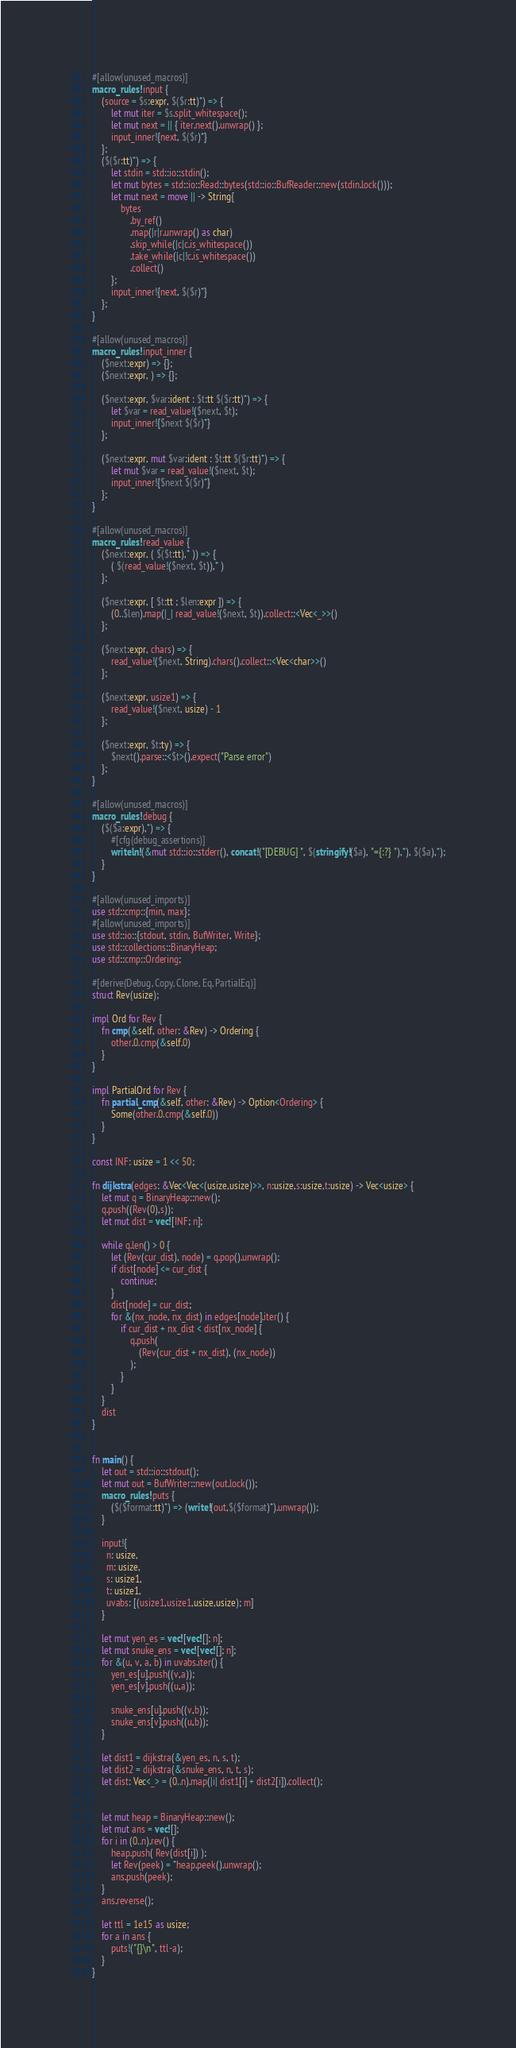<code> <loc_0><loc_0><loc_500><loc_500><_Rust_>#[allow(unused_macros)]
macro_rules! input {
    (source = $s:expr, $($r:tt)*) => {
        let mut iter = $s.split_whitespace();
        let mut next = || { iter.next().unwrap() };
        input_inner!{next, $($r)*}
    };
    ($($r:tt)*) => {
        let stdin = std::io::stdin();
        let mut bytes = std::io::Read::bytes(std::io::BufReader::new(stdin.lock()));
        let mut next = move || -> String{
            bytes
                .by_ref()
                .map(|r|r.unwrap() as char)
                .skip_while(|c|c.is_whitespace())
                .take_while(|c|!c.is_whitespace())
                .collect()
        };
        input_inner!{next, $($r)*}
    };
}

#[allow(unused_macros)]
macro_rules! input_inner {
    ($next:expr) => {};
    ($next:expr, ) => {};

    ($next:expr, $var:ident : $t:tt $($r:tt)*) => {
        let $var = read_value!($next, $t);
        input_inner!{$next $($r)*}
    };

    ($next:expr, mut $var:ident : $t:tt $($r:tt)*) => {
        let mut $var = read_value!($next, $t);
        input_inner!{$next $($r)*}
    };
}

#[allow(unused_macros)]
macro_rules! read_value {
    ($next:expr, ( $($t:tt),* )) => {
        ( $(read_value!($next, $t)),* )
    };

    ($next:expr, [ $t:tt ; $len:expr ]) => {
        (0..$len).map(|_| read_value!($next, $t)).collect::<Vec<_>>()
    };

    ($next:expr, chars) => {
        read_value!($next, String).chars().collect::<Vec<char>>()
    };

    ($next:expr, usize1) => {
        read_value!($next, usize) - 1
    };

    ($next:expr, $t:ty) => {
        $next().parse::<$t>().expect("Parse error")
    };
}

#[allow(unused_macros)]
macro_rules! debug {
    ($($a:expr),*) => {
        #[cfg(debug_assertions)]
        writeln!(&mut std::io::stderr(), concat!("[DEBUG] ", $(stringify!($a), "={:?} "),*), $($a),*);
    }
}

#[allow(unused_imports)]
use std::cmp::{min, max};
#[allow(unused_imports)]
use std::io::{stdout, stdin, BufWriter, Write};
use std::collections::BinaryHeap;
use std::cmp::Ordering;

#[derive(Debug, Copy, Clone, Eq, PartialEq)]
struct Rev(usize);

impl Ord for Rev {
    fn cmp(&self, other: &Rev) -> Ordering {
        other.0.cmp(&self.0)
    }
}

impl PartialOrd for Rev {
    fn partial_cmp(&self, other: &Rev) -> Option<Ordering> {
        Some(other.0.cmp(&self.0))
    }
}

const INF: usize = 1 << 50;

fn dijkstra(edges: &Vec<Vec<(usize,usize)>>, n:usize,s:usize,t:usize) -> Vec<usize> {
    let mut q = BinaryHeap::new();
    q.push((Rev(0),s));
    let mut dist = vec![INF; n];

    while q.len() > 0 {
        let (Rev(cur_dist), node) = q.pop().unwrap();
        if dist[node] <= cur_dist {
            continue;
        }
        dist[node] = cur_dist;
        for &(nx_node, nx_dist) in edges[node].iter() {
            if cur_dist + nx_dist < dist[nx_node] {
                q.push(
                    (Rev(cur_dist + nx_dist), (nx_node))
                );
            }
        }
    }
    dist
}


fn main() {
    let out = std::io::stdout();
    let mut out = BufWriter::new(out.lock());
    macro_rules! puts {
        ($($format:tt)*) => (write!(out,$($format)*).unwrap());
    }

    input!{
      n: usize,
      m: usize,
      s: usize1,
      t: usize1,
      uvabs: [(usize1,usize1,usize,usize); m]
    }

    let mut yen_es = vec![vec![]; n];
    let mut snuke_ens = vec![vec![]; n];
    for &(u, v, a, b) in uvabs.iter() {
        yen_es[u].push((v,a));
        yen_es[v].push((u,a));

        snuke_ens[u].push((v,b));
        snuke_ens[v].push((u,b));
    }

    let dist1 = dijkstra(&yen_es, n, s, t);
    let dist2 = dijkstra(&snuke_ens, n, t, s);
    let dist: Vec<_> = (0..n).map(|i| dist1[i] + dist2[i]).collect();


    let mut heap = BinaryHeap::new();
    let mut ans = vec![];
    for i in (0..n).rev() {
        heap.push( Rev(dist[i]) );
        let Rev(peek) = *heap.peek().unwrap();
        ans.push(peek);
    }
    ans.reverse();

    let ttl = 1e15 as usize;
    for a in ans {
        puts!("{}\n", ttl-a);
    }
}
</code> 